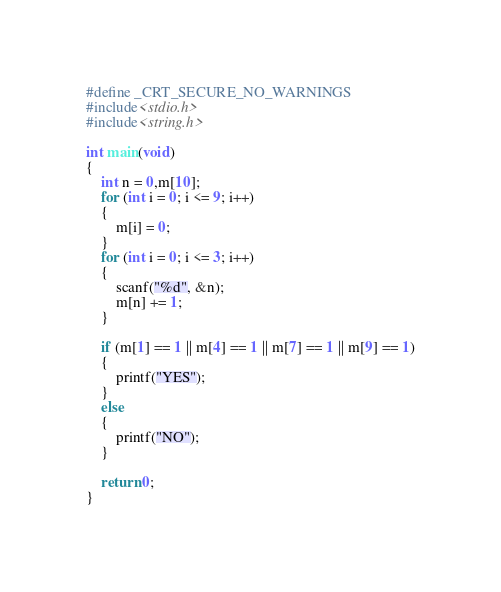Convert code to text. <code><loc_0><loc_0><loc_500><loc_500><_C_>#define _CRT_SECURE_NO_WARNINGS
#include<stdio.h>
#include<string.h>

int main(void)
{
	int n = 0,m[10];
	for (int i = 0; i <= 9; i++)
	{
		m[i] = 0;
	}
	for (int i = 0; i <= 3; i++)
	{
		scanf("%d", &n);
		m[n] += 1;
	}

	if (m[1] == 1 || m[4] == 1 || m[7] == 1 || m[9] == 1)
	{
		printf("YES");
	}
	else
	{
		printf("NO");
	}
	
	return 0;
}</code> 